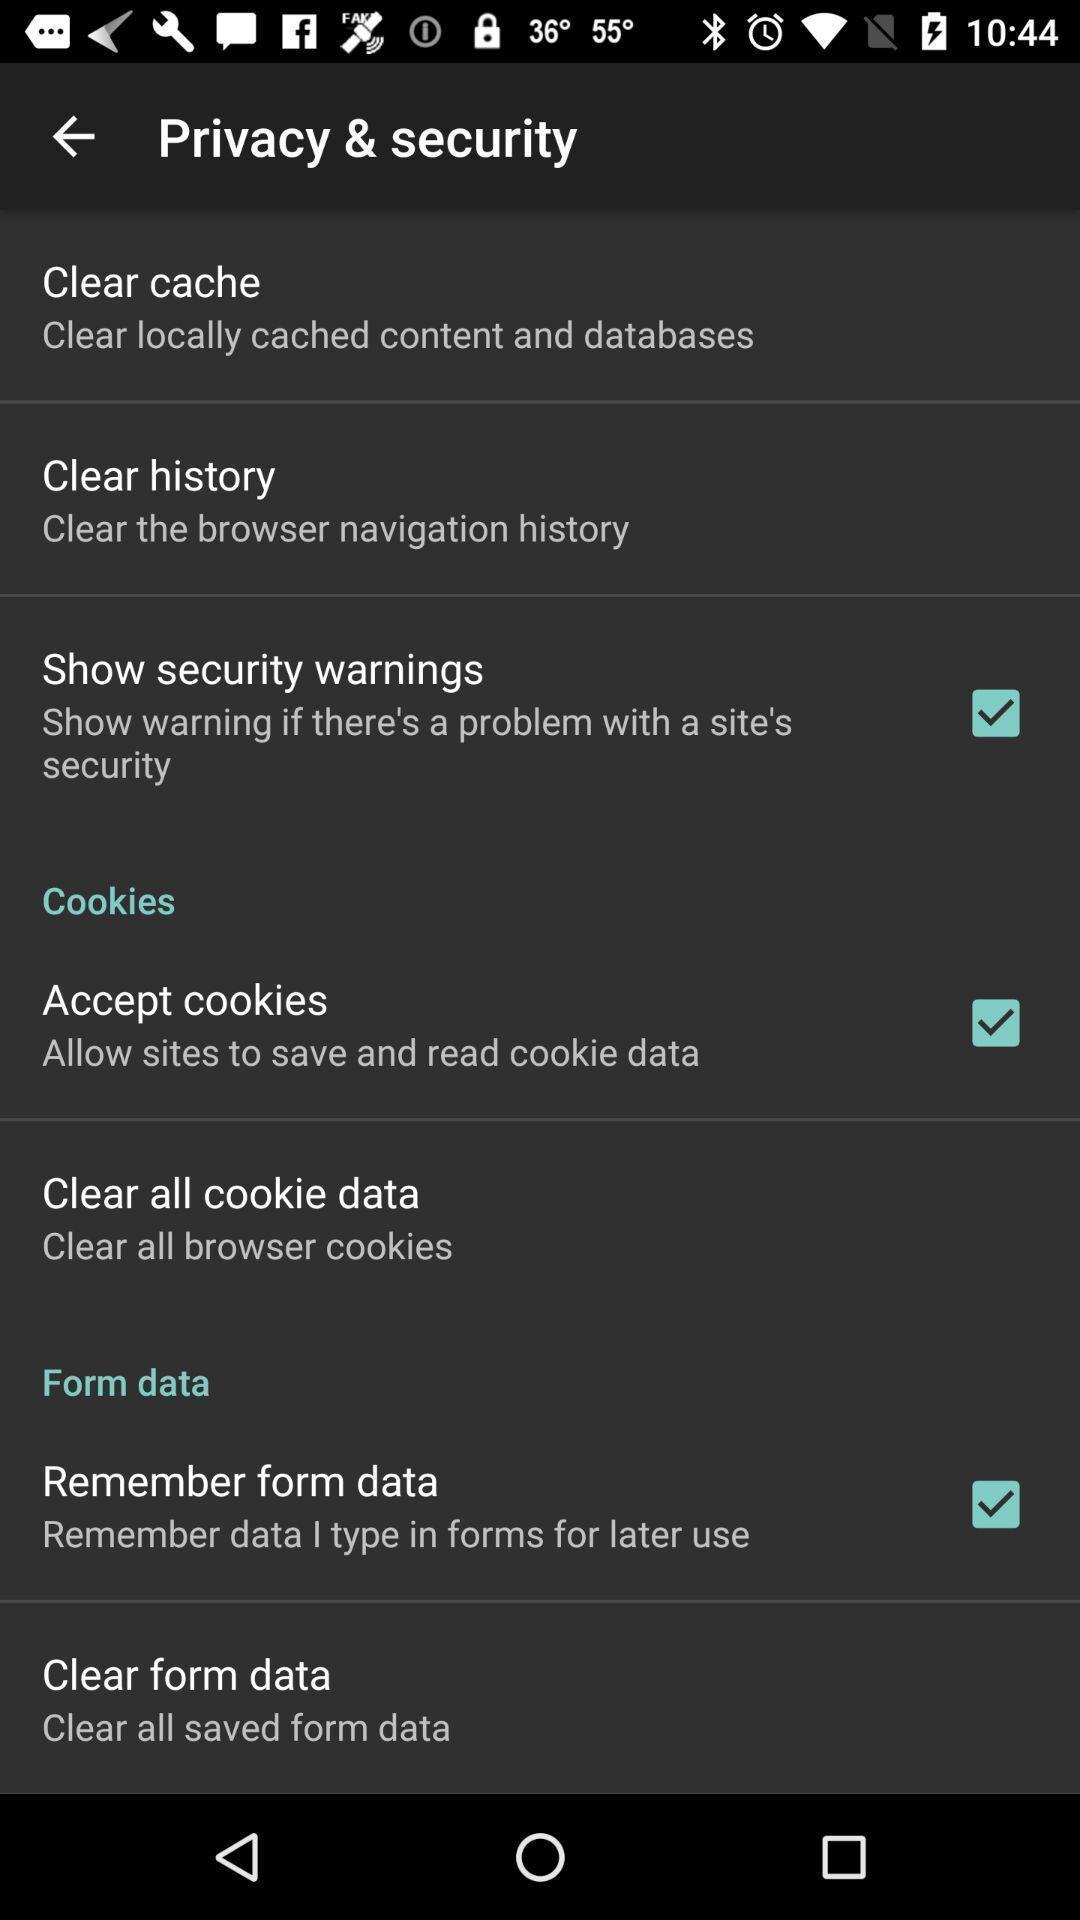Summarize the information in this screenshot. Screen shows privacy and security settings. 